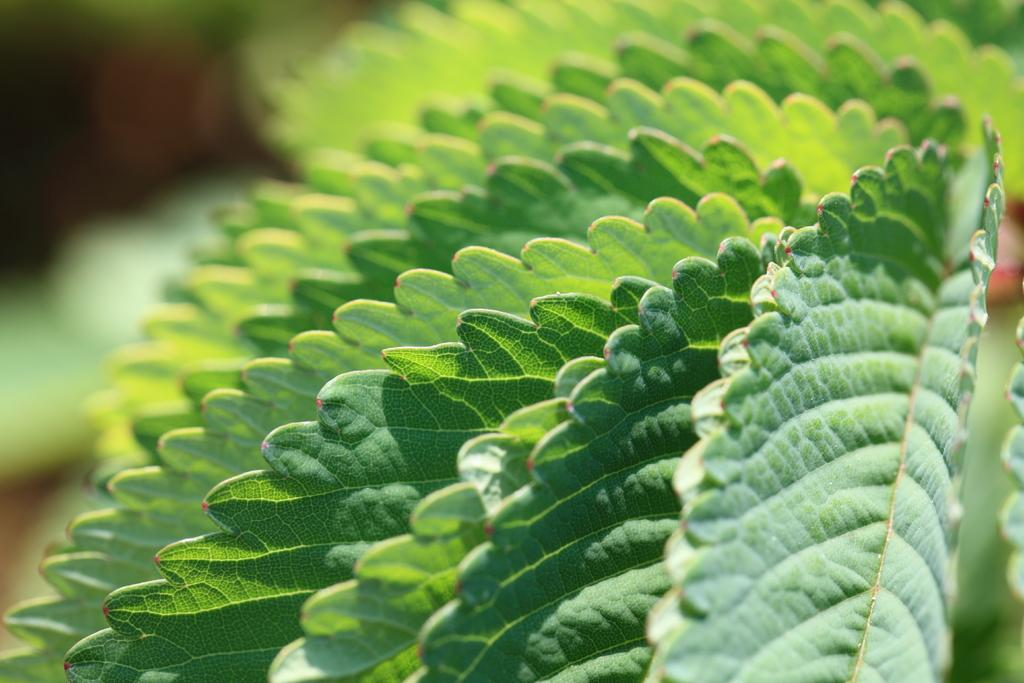What type of vegetation is visible in the front of the image? There are leaves in the front of the image. Can you describe the background of the image? The background of the image is blurry. What news story is being discussed in the image? There is no news story or discussion present in the image; it only features leaves in the front and a blurry background. 